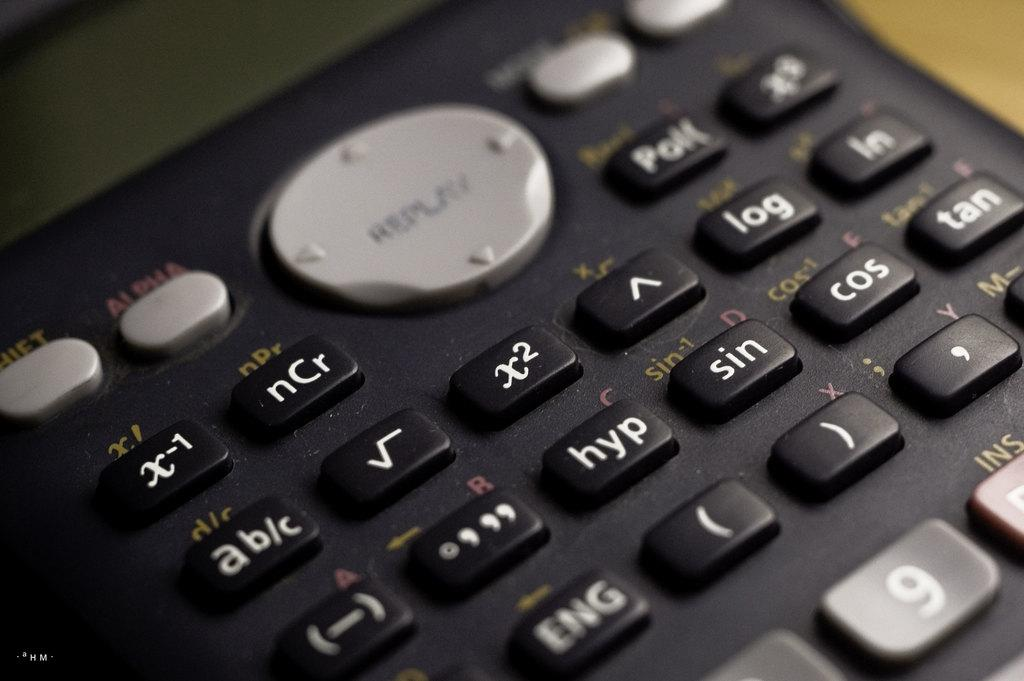<image>
Provide a brief description of the given image. A keypad arrangementhas keys for nCr, hyp, sin and more. 